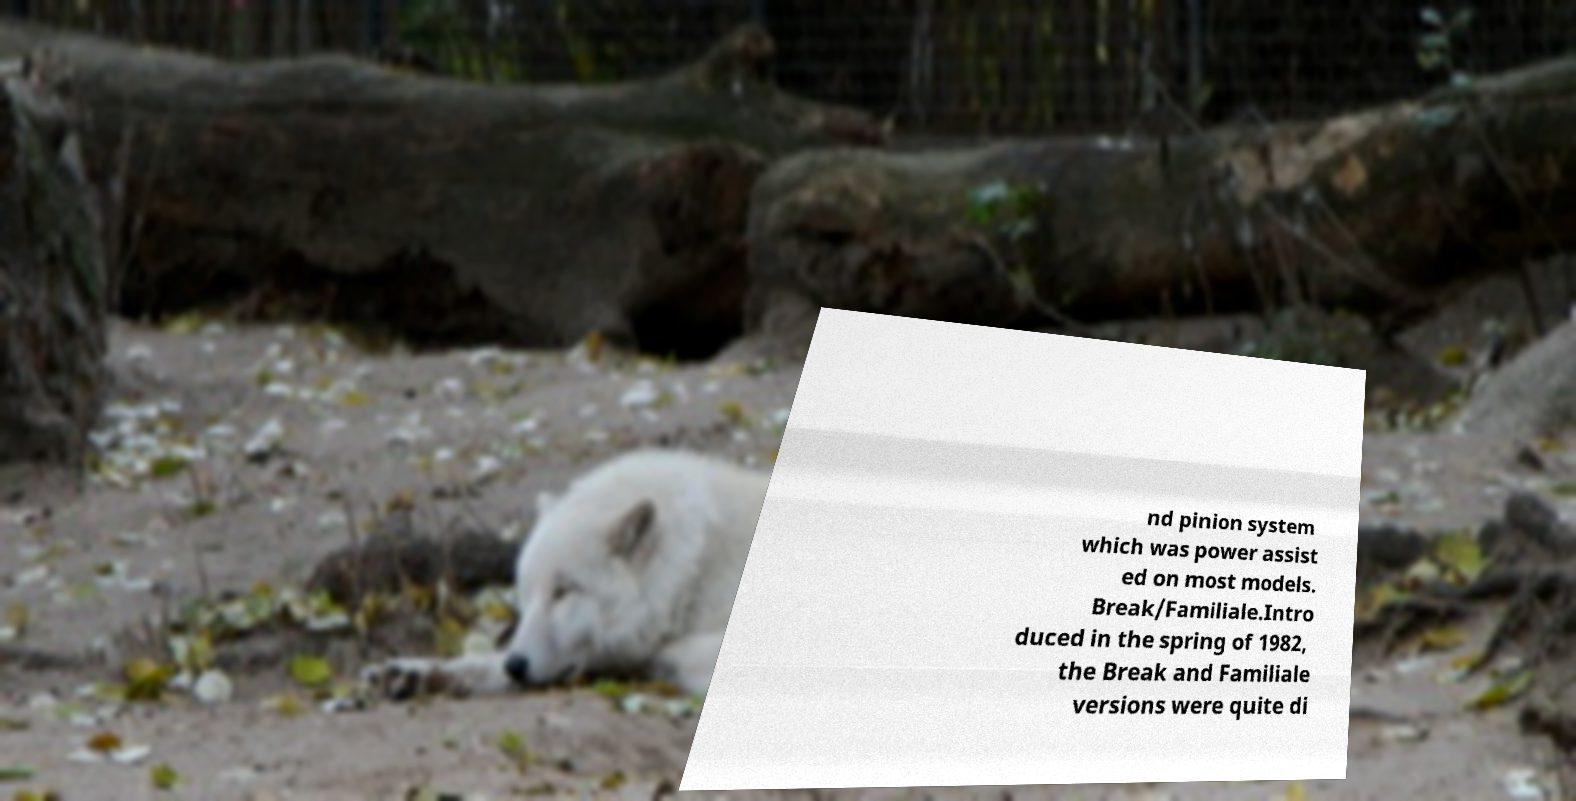Please read and relay the text visible in this image. What does it say? nd pinion system which was power assist ed on most models. Break/Familiale.Intro duced in the spring of 1982, the Break and Familiale versions were quite di 